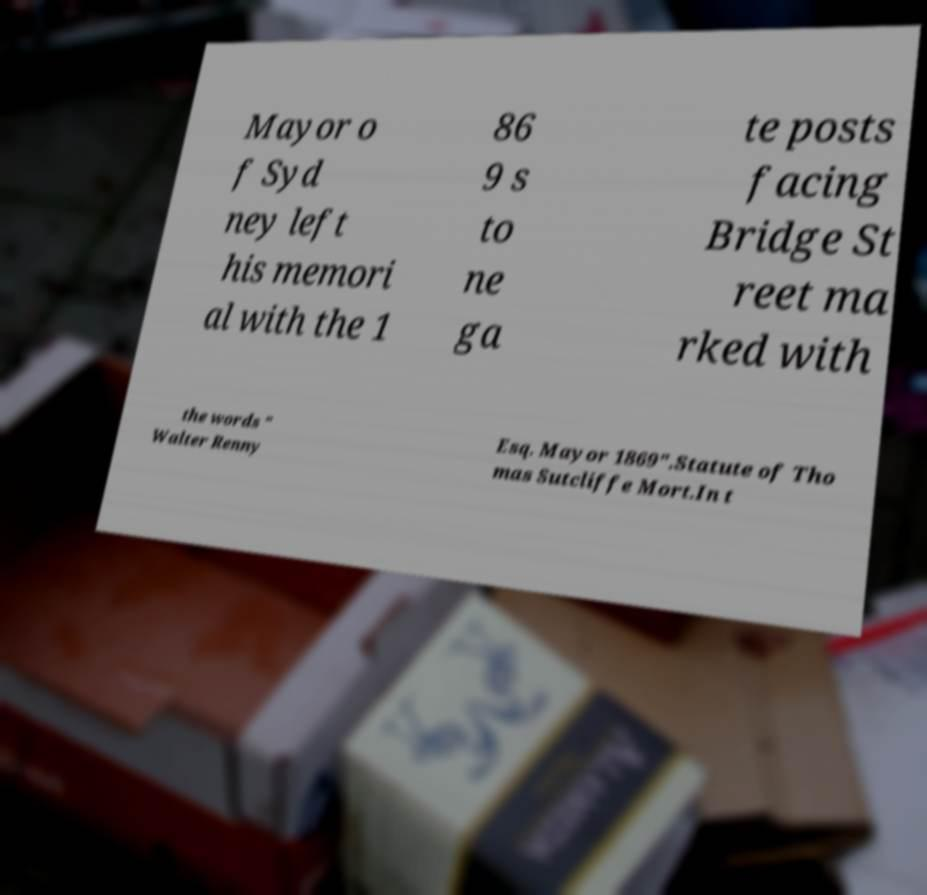Please identify and transcribe the text found in this image. Mayor o f Syd ney left his memori al with the 1 86 9 s to ne ga te posts facing Bridge St reet ma rked with the words " Walter Renny Esq. Mayor 1869".Statute of Tho mas Sutcliffe Mort.In t 